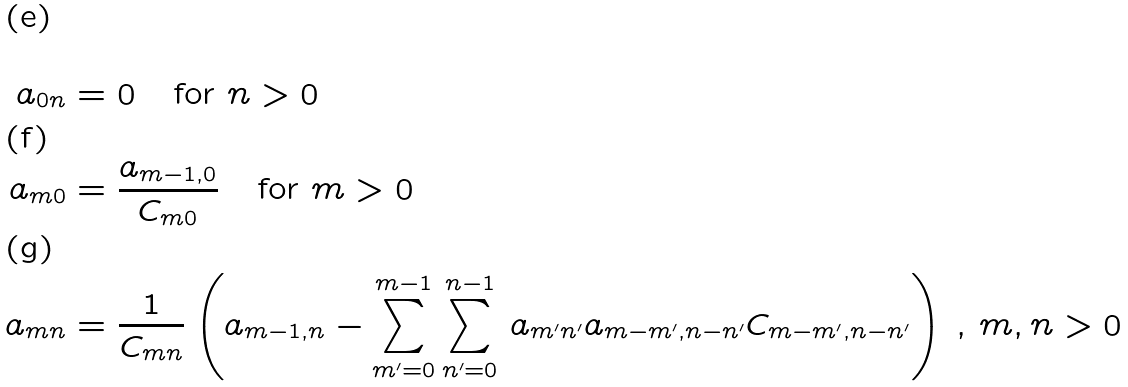<formula> <loc_0><loc_0><loc_500><loc_500>a _ { 0 n } & = 0 \quad \text {for $n>0$} \\ a _ { m 0 } & = \frac { a _ { m - 1 , 0 } } { C _ { m 0 } } \quad \text {for $m>0$} \\ a _ { m n } & = \frac { 1 } { C _ { m n } } \left ( a _ { m - 1 , n } - \sum _ { m ^ { \prime } = 0 } ^ { m - 1 } \sum _ { n ^ { \prime } = 0 } ^ { n - 1 } \, a _ { m ^ { \prime } n ^ { \prime } } a _ { m - m ^ { \prime } , n - n ^ { \prime } } C _ { m - m ^ { \prime } , n - n ^ { \prime } } \right ) \, , \, m , n > 0</formula> 